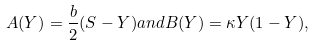Convert formula to latex. <formula><loc_0><loc_0><loc_500><loc_500>A ( Y ) = \frac { b } { 2 } ( S - Y ) a n d B ( Y ) = \kappa Y ( 1 - Y ) ,</formula> 